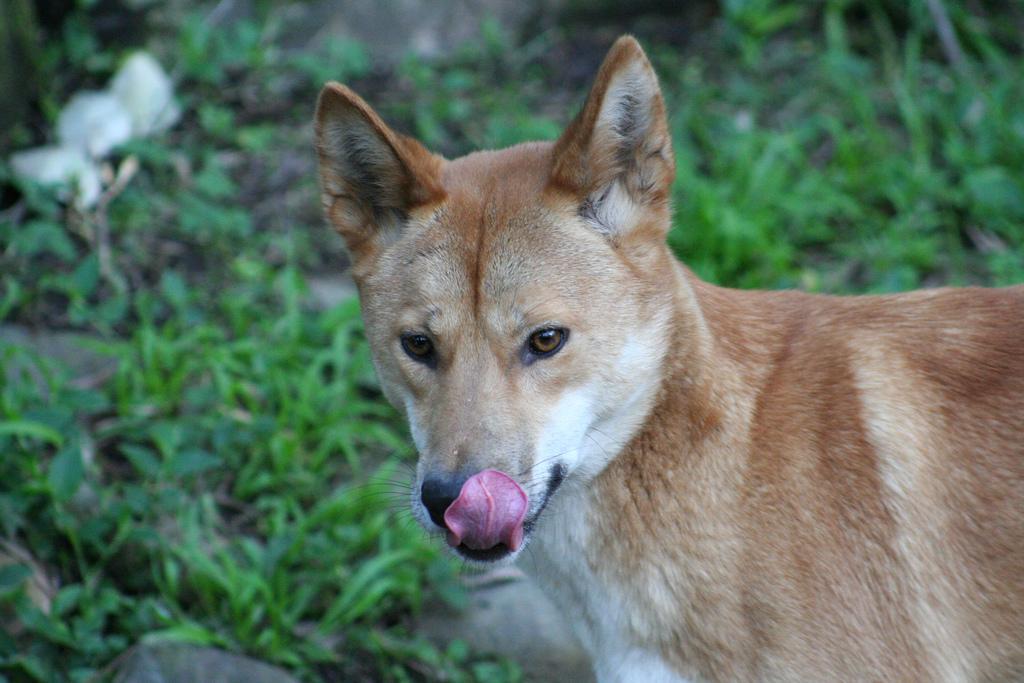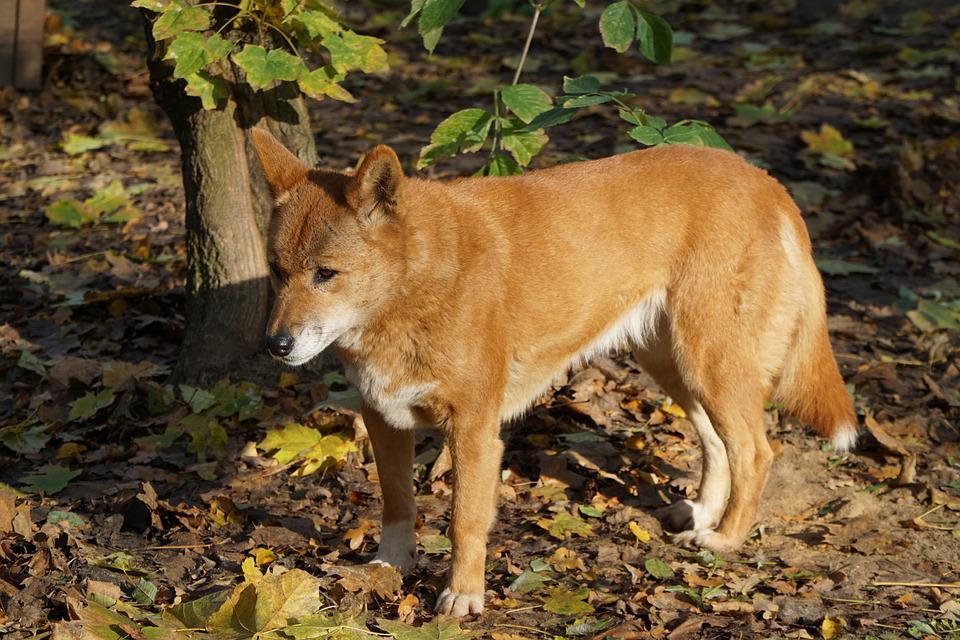The first image is the image on the left, the second image is the image on the right. For the images displayed, is the sentence "Each image shows only one wild dog, and the left image shows a dog with its body in profile turned rightward." factually correct? Answer yes or no. No. 